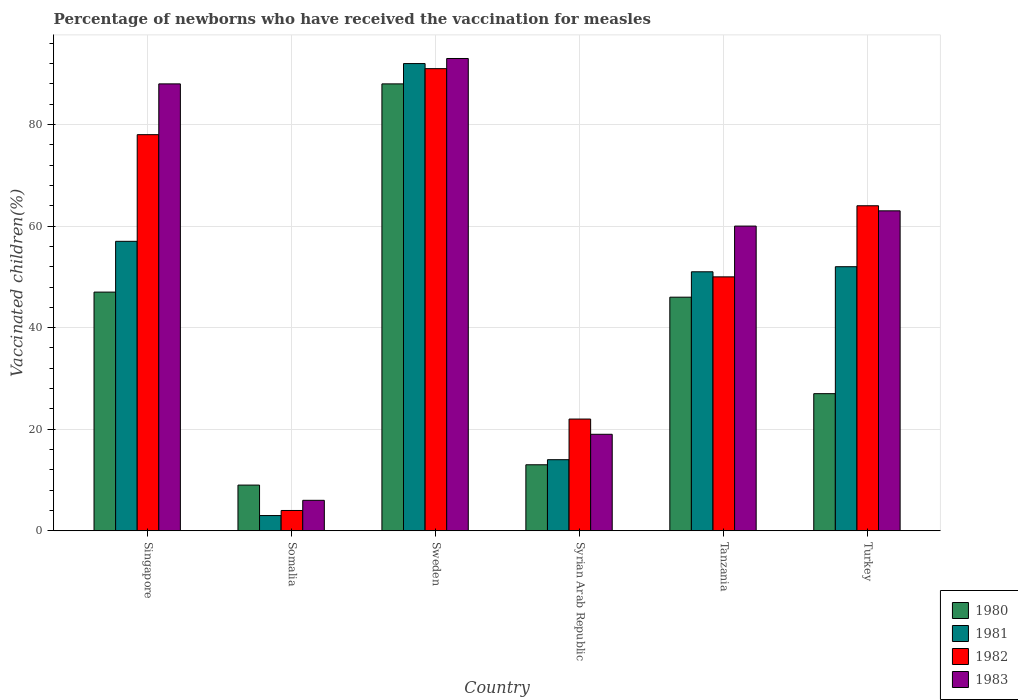Are the number of bars per tick equal to the number of legend labels?
Make the answer very short. Yes. Are the number of bars on each tick of the X-axis equal?
Provide a succinct answer. Yes. How many bars are there on the 1st tick from the left?
Keep it short and to the point. 4. How many bars are there on the 5th tick from the right?
Ensure brevity in your answer.  4. What is the label of the 2nd group of bars from the left?
Your answer should be compact. Somalia. What is the percentage of vaccinated children in 1980 in Turkey?
Offer a terse response. 27. In which country was the percentage of vaccinated children in 1983 minimum?
Keep it short and to the point. Somalia. What is the total percentage of vaccinated children in 1982 in the graph?
Ensure brevity in your answer.  309. What is the difference between the percentage of vaccinated children in 1980 in Syrian Arab Republic and the percentage of vaccinated children in 1982 in Tanzania?
Offer a very short reply. -37. What is the average percentage of vaccinated children in 1980 per country?
Provide a short and direct response. 38.33. In how many countries, is the percentage of vaccinated children in 1983 greater than 16 %?
Ensure brevity in your answer.  5. What is the ratio of the percentage of vaccinated children in 1980 in Singapore to that in Sweden?
Provide a short and direct response. 0.53. What is the difference between the highest and the second highest percentage of vaccinated children in 1981?
Make the answer very short. -35. What is the difference between the highest and the lowest percentage of vaccinated children in 1981?
Keep it short and to the point. 89. Is the sum of the percentage of vaccinated children in 1983 in Singapore and Tanzania greater than the maximum percentage of vaccinated children in 1982 across all countries?
Ensure brevity in your answer.  Yes. Are all the bars in the graph horizontal?
Give a very brief answer. No. How many countries are there in the graph?
Offer a terse response. 6. Are the values on the major ticks of Y-axis written in scientific E-notation?
Offer a very short reply. No. Does the graph contain grids?
Your answer should be very brief. Yes. Where does the legend appear in the graph?
Give a very brief answer. Bottom right. How many legend labels are there?
Provide a short and direct response. 4. What is the title of the graph?
Your answer should be compact. Percentage of newborns who have received the vaccination for measles. Does "2007" appear as one of the legend labels in the graph?
Your answer should be compact. No. What is the label or title of the Y-axis?
Your response must be concise. Vaccinated children(%). What is the Vaccinated children(%) of 1980 in Singapore?
Provide a short and direct response. 47. What is the Vaccinated children(%) in 1981 in Singapore?
Give a very brief answer. 57. What is the Vaccinated children(%) in 1980 in Somalia?
Give a very brief answer. 9. What is the Vaccinated children(%) in 1982 in Somalia?
Ensure brevity in your answer.  4. What is the Vaccinated children(%) in 1983 in Somalia?
Provide a succinct answer. 6. What is the Vaccinated children(%) in 1980 in Sweden?
Make the answer very short. 88. What is the Vaccinated children(%) in 1981 in Sweden?
Your response must be concise. 92. What is the Vaccinated children(%) in 1982 in Sweden?
Your answer should be very brief. 91. What is the Vaccinated children(%) in 1983 in Sweden?
Offer a very short reply. 93. What is the Vaccinated children(%) of 1980 in Tanzania?
Ensure brevity in your answer.  46. What is the Vaccinated children(%) of 1981 in Tanzania?
Your answer should be very brief. 51. What is the Vaccinated children(%) in 1980 in Turkey?
Give a very brief answer. 27. What is the Vaccinated children(%) in 1982 in Turkey?
Provide a succinct answer. 64. What is the Vaccinated children(%) in 1983 in Turkey?
Make the answer very short. 63. Across all countries, what is the maximum Vaccinated children(%) in 1981?
Ensure brevity in your answer.  92. Across all countries, what is the maximum Vaccinated children(%) in 1982?
Ensure brevity in your answer.  91. Across all countries, what is the maximum Vaccinated children(%) in 1983?
Give a very brief answer. 93. Across all countries, what is the minimum Vaccinated children(%) of 1980?
Offer a very short reply. 9. Across all countries, what is the minimum Vaccinated children(%) in 1981?
Provide a succinct answer. 3. What is the total Vaccinated children(%) of 1980 in the graph?
Offer a terse response. 230. What is the total Vaccinated children(%) in 1981 in the graph?
Offer a terse response. 269. What is the total Vaccinated children(%) in 1982 in the graph?
Make the answer very short. 309. What is the total Vaccinated children(%) in 1983 in the graph?
Your answer should be very brief. 329. What is the difference between the Vaccinated children(%) of 1982 in Singapore and that in Somalia?
Provide a short and direct response. 74. What is the difference between the Vaccinated children(%) of 1980 in Singapore and that in Sweden?
Your answer should be very brief. -41. What is the difference between the Vaccinated children(%) in 1981 in Singapore and that in Sweden?
Ensure brevity in your answer.  -35. What is the difference between the Vaccinated children(%) of 1983 in Singapore and that in Sweden?
Provide a succinct answer. -5. What is the difference between the Vaccinated children(%) of 1980 in Singapore and that in Syrian Arab Republic?
Offer a terse response. 34. What is the difference between the Vaccinated children(%) in 1981 in Singapore and that in Syrian Arab Republic?
Provide a short and direct response. 43. What is the difference between the Vaccinated children(%) of 1982 in Singapore and that in Syrian Arab Republic?
Provide a short and direct response. 56. What is the difference between the Vaccinated children(%) of 1980 in Singapore and that in Tanzania?
Offer a very short reply. 1. What is the difference between the Vaccinated children(%) in 1981 in Singapore and that in Tanzania?
Offer a very short reply. 6. What is the difference between the Vaccinated children(%) in 1983 in Singapore and that in Tanzania?
Ensure brevity in your answer.  28. What is the difference between the Vaccinated children(%) of 1982 in Singapore and that in Turkey?
Provide a short and direct response. 14. What is the difference between the Vaccinated children(%) of 1983 in Singapore and that in Turkey?
Your answer should be compact. 25. What is the difference between the Vaccinated children(%) of 1980 in Somalia and that in Sweden?
Offer a very short reply. -79. What is the difference between the Vaccinated children(%) in 1981 in Somalia and that in Sweden?
Make the answer very short. -89. What is the difference between the Vaccinated children(%) in 1982 in Somalia and that in Sweden?
Your answer should be compact. -87. What is the difference between the Vaccinated children(%) of 1983 in Somalia and that in Sweden?
Provide a short and direct response. -87. What is the difference between the Vaccinated children(%) in 1981 in Somalia and that in Syrian Arab Republic?
Keep it short and to the point. -11. What is the difference between the Vaccinated children(%) in 1982 in Somalia and that in Syrian Arab Republic?
Ensure brevity in your answer.  -18. What is the difference between the Vaccinated children(%) of 1980 in Somalia and that in Tanzania?
Your answer should be very brief. -37. What is the difference between the Vaccinated children(%) of 1981 in Somalia and that in Tanzania?
Your answer should be very brief. -48. What is the difference between the Vaccinated children(%) in 1982 in Somalia and that in Tanzania?
Your response must be concise. -46. What is the difference between the Vaccinated children(%) of 1983 in Somalia and that in Tanzania?
Ensure brevity in your answer.  -54. What is the difference between the Vaccinated children(%) in 1980 in Somalia and that in Turkey?
Your response must be concise. -18. What is the difference between the Vaccinated children(%) in 1981 in Somalia and that in Turkey?
Provide a succinct answer. -49. What is the difference between the Vaccinated children(%) of 1982 in Somalia and that in Turkey?
Give a very brief answer. -60. What is the difference between the Vaccinated children(%) in 1983 in Somalia and that in Turkey?
Provide a short and direct response. -57. What is the difference between the Vaccinated children(%) of 1981 in Sweden and that in Syrian Arab Republic?
Your response must be concise. 78. What is the difference between the Vaccinated children(%) in 1983 in Sweden and that in Syrian Arab Republic?
Ensure brevity in your answer.  74. What is the difference between the Vaccinated children(%) of 1980 in Sweden and that in Tanzania?
Offer a very short reply. 42. What is the difference between the Vaccinated children(%) in 1981 in Sweden and that in Tanzania?
Provide a succinct answer. 41. What is the difference between the Vaccinated children(%) in 1982 in Sweden and that in Tanzania?
Your response must be concise. 41. What is the difference between the Vaccinated children(%) of 1980 in Syrian Arab Republic and that in Tanzania?
Offer a terse response. -33. What is the difference between the Vaccinated children(%) in 1981 in Syrian Arab Republic and that in Tanzania?
Offer a very short reply. -37. What is the difference between the Vaccinated children(%) in 1983 in Syrian Arab Republic and that in Tanzania?
Ensure brevity in your answer.  -41. What is the difference between the Vaccinated children(%) of 1981 in Syrian Arab Republic and that in Turkey?
Provide a short and direct response. -38. What is the difference between the Vaccinated children(%) in 1982 in Syrian Arab Republic and that in Turkey?
Provide a succinct answer. -42. What is the difference between the Vaccinated children(%) in 1983 in Syrian Arab Republic and that in Turkey?
Give a very brief answer. -44. What is the difference between the Vaccinated children(%) in 1983 in Tanzania and that in Turkey?
Your response must be concise. -3. What is the difference between the Vaccinated children(%) of 1980 in Singapore and the Vaccinated children(%) of 1982 in Somalia?
Your answer should be compact. 43. What is the difference between the Vaccinated children(%) of 1981 in Singapore and the Vaccinated children(%) of 1982 in Somalia?
Provide a succinct answer. 53. What is the difference between the Vaccinated children(%) of 1982 in Singapore and the Vaccinated children(%) of 1983 in Somalia?
Your answer should be compact. 72. What is the difference between the Vaccinated children(%) in 1980 in Singapore and the Vaccinated children(%) in 1981 in Sweden?
Offer a very short reply. -45. What is the difference between the Vaccinated children(%) of 1980 in Singapore and the Vaccinated children(%) of 1982 in Sweden?
Make the answer very short. -44. What is the difference between the Vaccinated children(%) in 1980 in Singapore and the Vaccinated children(%) in 1983 in Sweden?
Offer a very short reply. -46. What is the difference between the Vaccinated children(%) in 1981 in Singapore and the Vaccinated children(%) in 1982 in Sweden?
Provide a short and direct response. -34. What is the difference between the Vaccinated children(%) of 1981 in Singapore and the Vaccinated children(%) of 1983 in Sweden?
Keep it short and to the point. -36. What is the difference between the Vaccinated children(%) of 1982 in Singapore and the Vaccinated children(%) of 1983 in Sweden?
Provide a short and direct response. -15. What is the difference between the Vaccinated children(%) in 1980 in Singapore and the Vaccinated children(%) in 1981 in Syrian Arab Republic?
Provide a succinct answer. 33. What is the difference between the Vaccinated children(%) of 1980 in Singapore and the Vaccinated children(%) of 1982 in Syrian Arab Republic?
Keep it short and to the point. 25. What is the difference between the Vaccinated children(%) of 1980 in Singapore and the Vaccinated children(%) of 1983 in Syrian Arab Republic?
Your answer should be very brief. 28. What is the difference between the Vaccinated children(%) in 1982 in Singapore and the Vaccinated children(%) in 1983 in Syrian Arab Republic?
Your answer should be very brief. 59. What is the difference between the Vaccinated children(%) in 1981 in Singapore and the Vaccinated children(%) in 1982 in Tanzania?
Offer a very short reply. 7. What is the difference between the Vaccinated children(%) in 1982 in Singapore and the Vaccinated children(%) in 1983 in Tanzania?
Offer a terse response. 18. What is the difference between the Vaccinated children(%) of 1981 in Singapore and the Vaccinated children(%) of 1982 in Turkey?
Provide a short and direct response. -7. What is the difference between the Vaccinated children(%) in 1982 in Singapore and the Vaccinated children(%) in 1983 in Turkey?
Provide a short and direct response. 15. What is the difference between the Vaccinated children(%) of 1980 in Somalia and the Vaccinated children(%) of 1981 in Sweden?
Your answer should be very brief. -83. What is the difference between the Vaccinated children(%) in 1980 in Somalia and the Vaccinated children(%) in 1982 in Sweden?
Offer a very short reply. -82. What is the difference between the Vaccinated children(%) of 1980 in Somalia and the Vaccinated children(%) of 1983 in Sweden?
Give a very brief answer. -84. What is the difference between the Vaccinated children(%) in 1981 in Somalia and the Vaccinated children(%) in 1982 in Sweden?
Your answer should be compact. -88. What is the difference between the Vaccinated children(%) of 1981 in Somalia and the Vaccinated children(%) of 1983 in Sweden?
Your answer should be compact. -90. What is the difference between the Vaccinated children(%) in 1982 in Somalia and the Vaccinated children(%) in 1983 in Sweden?
Your answer should be very brief. -89. What is the difference between the Vaccinated children(%) in 1980 in Somalia and the Vaccinated children(%) in 1983 in Syrian Arab Republic?
Offer a terse response. -10. What is the difference between the Vaccinated children(%) in 1981 in Somalia and the Vaccinated children(%) in 1982 in Syrian Arab Republic?
Your answer should be compact. -19. What is the difference between the Vaccinated children(%) of 1980 in Somalia and the Vaccinated children(%) of 1981 in Tanzania?
Keep it short and to the point. -42. What is the difference between the Vaccinated children(%) of 1980 in Somalia and the Vaccinated children(%) of 1982 in Tanzania?
Keep it short and to the point. -41. What is the difference between the Vaccinated children(%) in 1980 in Somalia and the Vaccinated children(%) in 1983 in Tanzania?
Provide a succinct answer. -51. What is the difference between the Vaccinated children(%) in 1981 in Somalia and the Vaccinated children(%) in 1982 in Tanzania?
Provide a short and direct response. -47. What is the difference between the Vaccinated children(%) in 1981 in Somalia and the Vaccinated children(%) in 1983 in Tanzania?
Give a very brief answer. -57. What is the difference between the Vaccinated children(%) in 1982 in Somalia and the Vaccinated children(%) in 1983 in Tanzania?
Offer a terse response. -56. What is the difference between the Vaccinated children(%) of 1980 in Somalia and the Vaccinated children(%) of 1981 in Turkey?
Give a very brief answer. -43. What is the difference between the Vaccinated children(%) in 1980 in Somalia and the Vaccinated children(%) in 1982 in Turkey?
Provide a succinct answer. -55. What is the difference between the Vaccinated children(%) of 1980 in Somalia and the Vaccinated children(%) of 1983 in Turkey?
Provide a short and direct response. -54. What is the difference between the Vaccinated children(%) in 1981 in Somalia and the Vaccinated children(%) in 1982 in Turkey?
Give a very brief answer. -61. What is the difference between the Vaccinated children(%) of 1981 in Somalia and the Vaccinated children(%) of 1983 in Turkey?
Keep it short and to the point. -60. What is the difference between the Vaccinated children(%) of 1982 in Somalia and the Vaccinated children(%) of 1983 in Turkey?
Keep it short and to the point. -59. What is the difference between the Vaccinated children(%) of 1980 in Sweden and the Vaccinated children(%) of 1981 in Syrian Arab Republic?
Keep it short and to the point. 74. What is the difference between the Vaccinated children(%) in 1981 in Sweden and the Vaccinated children(%) in 1982 in Syrian Arab Republic?
Offer a terse response. 70. What is the difference between the Vaccinated children(%) of 1981 in Sweden and the Vaccinated children(%) of 1983 in Syrian Arab Republic?
Ensure brevity in your answer.  73. What is the difference between the Vaccinated children(%) of 1982 in Sweden and the Vaccinated children(%) of 1983 in Syrian Arab Republic?
Your response must be concise. 72. What is the difference between the Vaccinated children(%) of 1980 in Sweden and the Vaccinated children(%) of 1981 in Tanzania?
Your answer should be very brief. 37. What is the difference between the Vaccinated children(%) of 1980 in Sweden and the Vaccinated children(%) of 1982 in Tanzania?
Provide a succinct answer. 38. What is the difference between the Vaccinated children(%) of 1981 in Sweden and the Vaccinated children(%) of 1982 in Tanzania?
Provide a short and direct response. 42. What is the difference between the Vaccinated children(%) in 1981 in Sweden and the Vaccinated children(%) in 1983 in Tanzania?
Offer a terse response. 32. What is the difference between the Vaccinated children(%) in 1982 in Sweden and the Vaccinated children(%) in 1983 in Tanzania?
Your response must be concise. 31. What is the difference between the Vaccinated children(%) of 1980 in Sweden and the Vaccinated children(%) of 1982 in Turkey?
Your answer should be very brief. 24. What is the difference between the Vaccinated children(%) in 1981 in Sweden and the Vaccinated children(%) in 1983 in Turkey?
Offer a terse response. 29. What is the difference between the Vaccinated children(%) in 1982 in Sweden and the Vaccinated children(%) in 1983 in Turkey?
Give a very brief answer. 28. What is the difference between the Vaccinated children(%) of 1980 in Syrian Arab Republic and the Vaccinated children(%) of 1981 in Tanzania?
Make the answer very short. -38. What is the difference between the Vaccinated children(%) in 1980 in Syrian Arab Republic and the Vaccinated children(%) in 1982 in Tanzania?
Your answer should be very brief. -37. What is the difference between the Vaccinated children(%) of 1980 in Syrian Arab Republic and the Vaccinated children(%) of 1983 in Tanzania?
Make the answer very short. -47. What is the difference between the Vaccinated children(%) in 1981 in Syrian Arab Republic and the Vaccinated children(%) in 1982 in Tanzania?
Keep it short and to the point. -36. What is the difference between the Vaccinated children(%) in 1981 in Syrian Arab Republic and the Vaccinated children(%) in 1983 in Tanzania?
Provide a succinct answer. -46. What is the difference between the Vaccinated children(%) in 1982 in Syrian Arab Republic and the Vaccinated children(%) in 1983 in Tanzania?
Give a very brief answer. -38. What is the difference between the Vaccinated children(%) of 1980 in Syrian Arab Republic and the Vaccinated children(%) of 1981 in Turkey?
Your answer should be compact. -39. What is the difference between the Vaccinated children(%) of 1980 in Syrian Arab Republic and the Vaccinated children(%) of 1982 in Turkey?
Make the answer very short. -51. What is the difference between the Vaccinated children(%) of 1981 in Syrian Arab Republic and the Vaccinated children(%) of 1982 in Turkey?
Ensure brevity in your answer.  -50. What is the difference between the Vaccinated children(%) of 1981 in Syrian Arab Republic and the Vaccinated children(%) of 1983 in Turkey?
Keep it short and to the point. -49. What is the difference between the Vaccinated children(%) in 1982 in Syrian Arab Republic and the Vaccinated children(%) in 1983 in Turkey?
Keep it short and to the point. -41. What is the difference between the Vaccinated children(%) in 1980 in Tanzania and the Vaccinated children(%) in 1981 in Turkey?
Ensure brevity in your answer.  -6. What is the difference between the Vaccinated children(%) of 1980 in Tanzania and the Vaccinated children(%) of 1983 in Turkey?
Offer a very short reply. -17. What is the difference between the Vaccinated children(%) in 1981 in Tanzania and the Vaccinated children(%) in 1983 in Turkey?
Give a very brief answer. -12. What is the difference between the Vaccinated children(%) in 1982 in Tanzania and the Vaccinated children(%) in 1983 in Turkey?
Provide a short and direct response. -13. What is the average Vaccinated children(%) of 1980 per country?
Give a very brief answer. 38.33. What is the average Vaccinated children(%) in 1981 per country?
Your answer should be very brief. 44.83. What is the average Vaccinated children(%) of 1982 per country?
Your response must be concise. 51.5. What is the average Vaccinated children(%) in 1983 per country?
Your response must be concise. 54.83. What is the difference between the Vaccinated children(%) in 1980 and Vaccinated children(%) in 1982 in Singapore?
Offer a very short reply. -31. What is the difference between the Vaccinated children(%) of 1980 and Vaccinated children(%) of 1983 in Singapore?
Give a very brief answer. -41. What is the difference between the Vaccinated children(%) of 1981 and Vaccinated children(%) of 1982 in Singapore?
Keep it short and to the point. -21. What is the difference between the Vaccinated children(%) of 1981 and Vaccinated children(%) of 1983 in Singapore?
Your response must be concise. -31. What is the difference between the Vaccinated children(%) in 1982 and Vaccinated children(%) in 1983 in Singapore?
Your answer should be compact. -10. What is the difference between the Vaccinated children(%) in 1980 and Vaccinated children(%) in 1982 in Somalia?
Provide a short and direct response. 5. What is the difference between the Vaccinated children(%) of 1980 and Vaccinated children(%) of 1983 in Somalia?
Give a very brief answer. 3. What is the difference between the Vaccinated children(%) of 1980 and Vaccinated children(%) of 1981 in Sweden?
Your answer should be compact. -4. What is the difference between the Vaccinated children(%) in 1980 and Vaccinated children(%) in 1982 in Sweden?
Offer a very short reply. -3. What is the difference between the Vaccinated children(%) in 1981 and Vaccinated children(%) in 1983 in Sweden?
Offer a terse response. -1. What is the difference between the Vaccinated children(%) in 1982 and Vaccinated children(%) in 1983 in Sweden?
Provide a short and direct response. -2. What is the difference between the Vaccinated children(%) in 1980 and Vaccinated children(%) in 1983 in Syrian Arab Republic?
Provide a short and direct response. -6. What is the difference between the Vaccinated children(%) of 1981 and Vaccinated children(%) of 1982 in Syrian Arab Republic?
Give a very brief answer. -8. What is the difference between the Vaccinated children(%) in 1981 and Vaccinated children(%) in 1982 in Tanzania?
Keep it short and to the point. 1. What is the difference between the Vaccinated children(%) in 1982 and Vaccinated children(%) in 1983 in Tanzania?
Your response must be concise. -10. What is the difference between the Vaccinated children(%) of 1980 and Vaccinated children(%) of 1982 in Turkey?
Ensure brevity in your answer.  -37. What is the difference between the Vaccinated children(%) in 1980 and Vaccinated children(%) in 1983 in Turkey?
Give a very brief answer. -36. What is the difference between the Vaccinated children(%) of 1981 and Vaccinated children(%) of 1983 in Turkey?
Your response must be concise. -11. What is the difference between the Vaccinated children(%) of 1982 and Vaccinated children(%) of 1983 in Turkey?
Provide a short and direct response. 1. What is the ratio of the Vaccinated children(%) of 1980 in Singapore to that in Somalia?
Provide a succinct answer. 5.22. What is the ratio of the Vaccinated children(%) in 1981 in Singapore to that in Somalia?
Offer a terse response. 19. What is the ratio of the Vaccinated children(%) of 1982 in Singapore to that in Somalia?
Your answer should be very brief. 19.5. What is the ratio of the Vaccinated children(%) in 1983 in Singapore to that in Somalia?
Ensure brevity in your answer.  14.67. What is the ratio of the Vaccinated children(%) in 1980 in Singapore to that in Sweden?
Provide a short and direct response. 0.53. What is the ratio of the Vaccinated children(%) in 1981 in Singapore to that in Sweden?
Provide a short and direct response. 0.62. What is the ratio of the Vaccinated children(%) in 1982 in Singapore to that in Sweden?
Keep it short and to the point. 0.86. What is the ratio of the Vaccinated children(%) of 1983 in Singapore to that in Sweden?
Your answer should be compact. 0.95. What is the ratio of the Vaccinated children(%) in 1980 in Singapore to that in Syrian Arab Republic?
Make the answer very short. 3.62. What is the ratio of the Vaccinated children(%) in 1981 in Singapore to that in Syrian Arab Republic?
Your response must be concise. 4.07. What is the ratio of the Vaccinated children(%) in 1982 in Singapore to that in Syrian Arab Republic?
Your response must be concise. 3.55. What is the ratio of the Vaccinated children(%) in 1983 in Singapore to that in Syrian Arab Republic?
Give a very brief answer. 4.63. What is the ratio of the Vaccinated children(%) in 1980 in Singapore to that in Tanzania?
Keep it short and to the point. 1.02. What is the ratio of the Vaccinated children(%) in 1981 in Singapore to that in Tanzania?
Keep it short and to the point. 1.12. What is the ratio of the Vaccinated children(%) in 1982 in Singapore to that in Tanzania?
Keep it short and to the point. 1.56. What is the ratio of the Vaccinated children(%) of 1983 in Singapore to that in Tanzania?
Make the answer very short. 1.47. What is the ratio of the Vaccinated children(%) in 1980 in Singapore to that in Turkey?
Your answer should be compact. 1.74. What is the ratio of the Vaccinated children(%) of 1981 in Singapore to that in Turkey?
Offer a terse response. 1.1. What is the ratio of the Vaccinated children(%) in 1982 in Singapore to that in Turkey?
Your answer should be very brief. 1.22. What is the ratio of the Vaccinated children(%) in 1983 in Singapore to that in Turkey?
Your answer should be compact. 1.4. What is the ratio of the Vaccinated children(%) in 1980 in Somalia to that in Sweden?
Your answer should be very brief. 0.1. What is the ratio of the Vaccinated children(%) of 1981 in Somalia to that in Sweden?
Make the answer very short. 0.03. What is the ratio of the Vaccinated children(%) of 1982 in Somalia to that in Sweden?
Provide a succinct answer. 0.04. What is the ratio of the Vaccinated children(%) of 1983 in Somalia to that in Sweden?
Your answer should be compact. 0.06. What is the ratio of the Vaccinated children(%) of 1980 in Somalia to that in Syrian Arab Republic?
Your answer should be compact. 0.69. What is the ratio of the Vaccinated children(%) of 1981 in Somalia to that in Syrian Arab Republic?
Your answer should be very brief. 0.21. What is the ratio of the Vaccinated children(%) in 1982 in Somalia to that in Syrian Arab Republic?
Offer a terse response. 0.18. What is the ratio of the Vaccinated children(%) of 1983 in Somalia to that in Syrian Arab Republic?
Ensure brevity in your answer.  0.32. What is the ratio of the Vaccinated children(%) in 1980 in Somalia to that in Tanzania?
Give a very brief answer. 0.2. What is the ratio of the Vaccinated children(%) of 1981 in Somalia to that in Tanzania?
Offer a very short reply. 0.06. What is the ratio of the Vaccinated children(%) of 1983 in Somalia to that in Tanzania?
Your answer should be very brief. 0.1. What is the ratio of the Vaccinated children(%) in 1980 in Somalia to that in Turkey?
Make the answer very short. 0.33. What is the ratio of the Vaccinated children(%) of 1981 in Somalia to that in Turkey?
Provide a succinct answer. 0.06. What is the ratio of the Vaccinated children(%) of 1982 in Somalia to that in Turkey?
Offer a terse response. 0.06. What is the ratio of the Vaccinated children(%) in 1983 in Somalia to that in Turkey?
Offer a terse response. 0.1. What is the ratio of the Vaccinated children(%) of 1980 in Sweden to that in Syrian Arab Republic?
Provide a short and direct response. 6.77. What is the ratio of the Vaccinated children(%) of 1981 in Sweden to that in Syrian Arab Republic?
Your answer should be very brief. 6.57. What is the ratio of the Vaccinated children(%) in 1982 in Sweden to that in Syrian Arab Republic?
Your response must be concise. 4.14. What is the ratio of the Vaccinated children(%) of 1983 in Sweden to that in Syrian Arab Republic?
Offer a very short reply. 4.89. What is the ratio of the Vaccinated children(%) in 1980 in Sweden to that in Tanzania?
Provide a short and direct response. 1.91. What is the ratio of the Vaccinated children(%) in 1981 in Sweden to that in Tanzania?
Offer a very short reply. 1.8. What is the ratio of the Vaccinated children(%) of 1982 in Sweden to that in Tanzania?
Give a very brief answer. 1.82. What is the ratio of the Vaccinated children(%) in 1983 in Sweden to that in Tanzania?
Your answer should be very brief. 1.55. What is the ratio of the Vaccinated children(%) of 1980 in Sweden to that in Turkey?
Your answer should be very brief. 3.26. What is the ratio of the Vaccinated children(%) of 1981 in Sweden to that in Turkey?
Provide a short and direct response. 1.77. What is the ratio of the Vaccinated children(%) in 1982 in Sweden to that in Turkey?
Your response must be concise. 1.42. What is the ratio of the Vaccinated children(%) of 1983 in Sweden to that in Turkey?
Provide a succinct answer. 1.48. What is the ratio of the Vaccinated children(%) in 1980 in Syrian Arab Republic to that in Tanzania?
Keep it short and to the point. 0.28. What is the ratio of the Vaccinated children(%) of 1981 in Syrian Arab Republic to that in Tanzania?
Offer a very short reply. 0.27. What is the ratio of the Vaccinated children(%) of 1982 in Syrian Arab Republic to that in Tanzania?
Make the answer very short. 0.44. What is the ratio of the Vaccinated children(%) in 1983 in Syrian Arab Republic to that in Tanzania?
Ensure brevity in your answer.  0.32. What is the ratio of the Vaccinated children(%) of 1980 in Syrian Arab Republic to that in Turkey?
Make the answer very short. 0.48. What is the ratio of the Vaccinated children(%) of 1981 in Syrian Arab Republic to that in Turkey?
Ensure brevity in your answer.  0.27. What is the ratio of the Vaccinated children(%) of 1982 in Syrian Arab Republic to that in Turkey?
Provide a succinct answer. 0.34. What is the ratio of the Vaccinated children(%) of 1983 in Syrian Arab Republic to that in Turkey?
Make the answer very short. 0.3. What is the ratio of the Vaccinated children(%) in 1980 in Tanzania to that in Turkey?
Your answer should be very brief. 1.7. What is the ratio of the Vaccinated children(%) of 1981 in Tanzania to that in Turkey?
Provide a succinct answer. 0.98. What is the ratio of the Vaccinated children(%) in 1982 in Tanzania to that in Turkey?
Give a very brief answer. 0.78. What is the ratio of the Vaccinated children(%) in 1983 in Tanzania to that in Turkey?
Give a very brief answer. 0.95. What is the difference between the highest and the second highest Vaccinated children(%) in 1980?
Keep it short and to the point. 41. What is the difference between the highest and the second highest Vaccinated children(%) in 1981?
Your response must be concise. 35. What is the difference between the highest and the second highest Vaccinated children(%) in 1982?
Ensure brevity in your answer.  13. What is the difference between the highest and the lowest Vaccinated children(%) in 1980?
Keep it short and to the point. 79. What is the difference between the highest and the lowest Vaccinated children(%) in 1981?
Give a very brief answer. 89. What is the difference between the highest and the lowest Vaccinated children(%) of 1983?
Your answer should be compact. 87. 